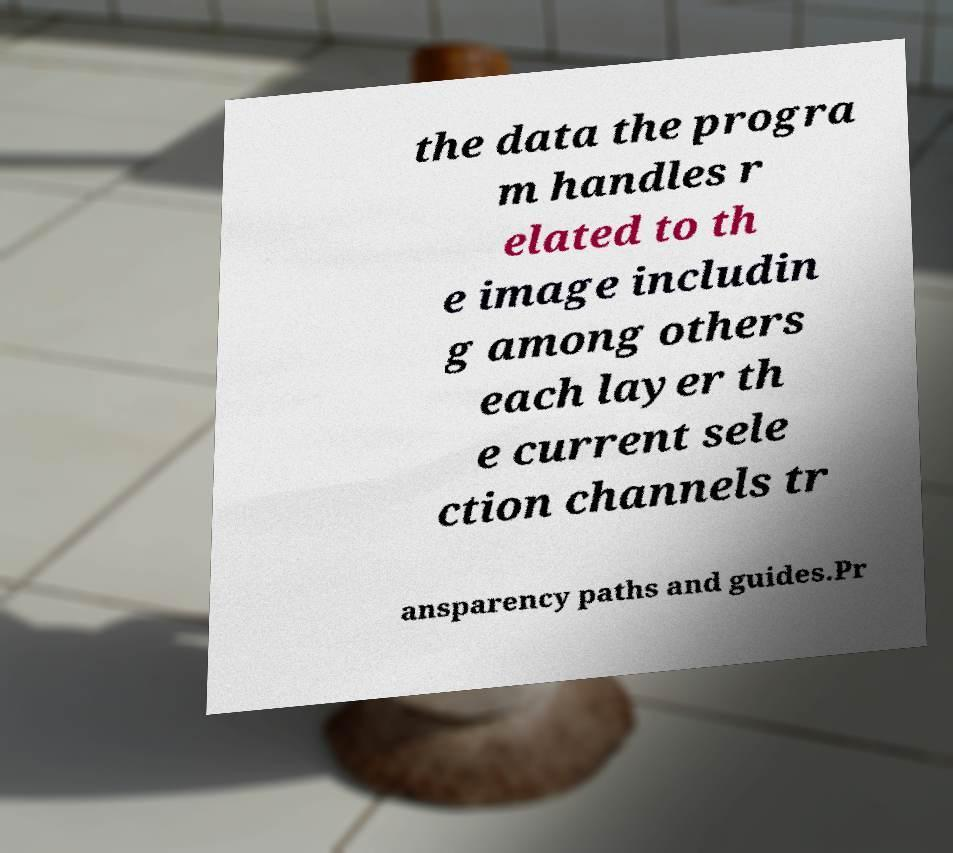Can you accurately transcribe the text from the provided image for me? the data the progra m handles r elated to th e image includin g among others each layer th e current sele ction channels tr ansparency paths and guides.Pr 